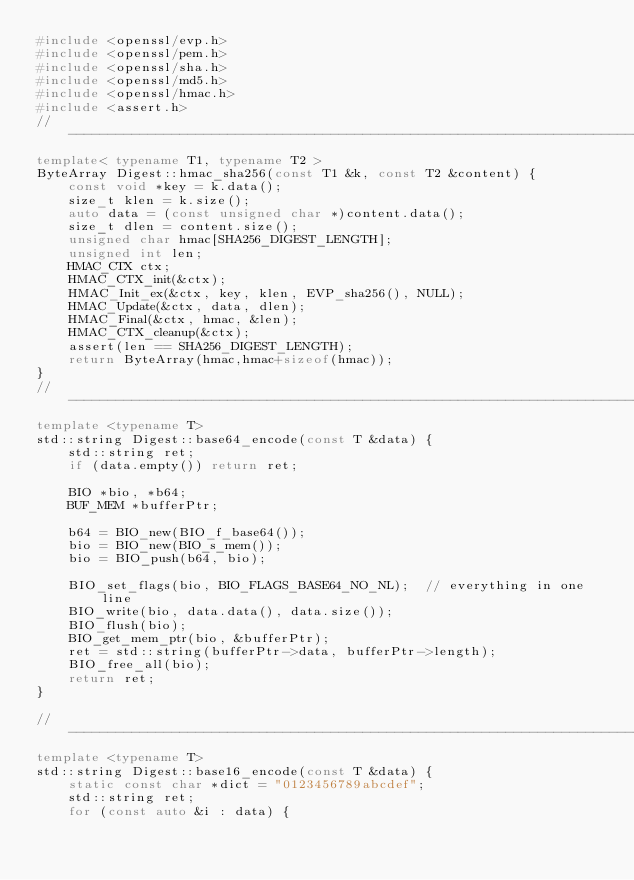<code> <loc_0><loc_0><loc_500><loc_500><_C++_>#include <openssl/evp.h>
#include <openssl/pem.h>
#include <openssl/sha.h>
#include <openssl/md5.h>
#include <openssl/hmac.h>
#include <assert.h>
//------------------------------------------------------------------------------
template< typename T1, typename T2 >
ByteArray Digest::hmac_sha256(const T1 &k, const T2 &content) {
    const void *key = k.data();
    size_t klen = k.size();
    auto data = (const unsigned char *)content.data();
    size_t dlen = content.size();
    unsigned char hmac[SHA256_DIGEST_LENGTH];
    unsigned int len;
    HMAC_CTX ctx;
    HMAC_CTX_init(&ctx);
    HMAC_Init_ex(&ctx, key, klen, EVP_sha256(), NULL);
    HMAC_Update(&ctx, data, dlen);
    HMAC_Final(&ctx, hmac, &len);
    HMAC_CTX_cleanup(&ctx);
    assert(len == SHA256_DIGEST_LENGTH);
    return ByteArray(hmac,hmac+sizeof(hmac));
}
//------------------------------------------------------------------------------
template <typename T>
std::string Digest::base64_encode(const T &data) {
    std::string ret;
    if (data.empty()) return ret;

    BIO *bio, *b64;
    BUF_MEM *bufferPtr;

    b64 = BIO_new(BIO_f_base64());
    bio = BIO_new(BIO_s_mem());
    bio = BIO_push(b64, bio);

    BIO_set_flags(bio, BIO_FLAGS_BASE64_NO_NL);  // everything in one line
    BIO_write(bio, data.data(), data.size());
    BIO_flush(bio);
    BIO_get_mem_ptr(bio, &bufferPtr);
    ret = std::string(bufferPtr->data, bufferPtr->length);
    BIO_free_all(bio);
    return ret;
}

//------------------------------------------------------------------------------
template <typename T>
std::string Digest::base16_encode(const T &data) {
    static const char *dict = "0123456789abcdef";
    std::string ret;
    for (const auto &i : data) {</code> 